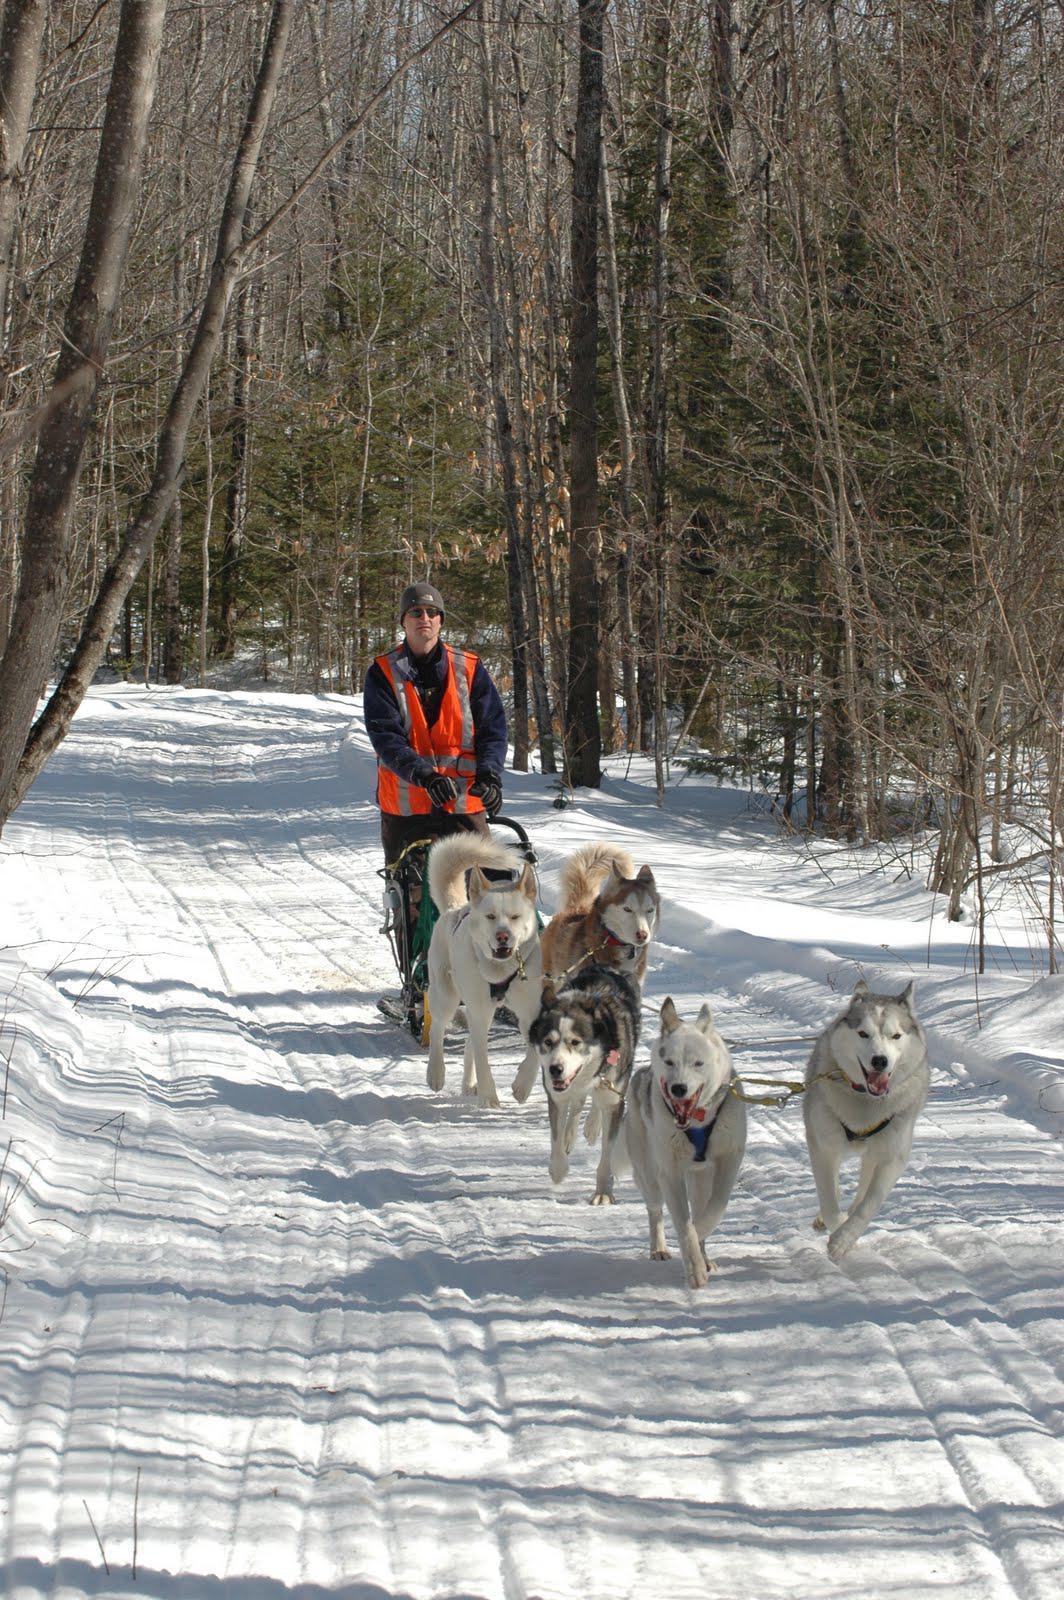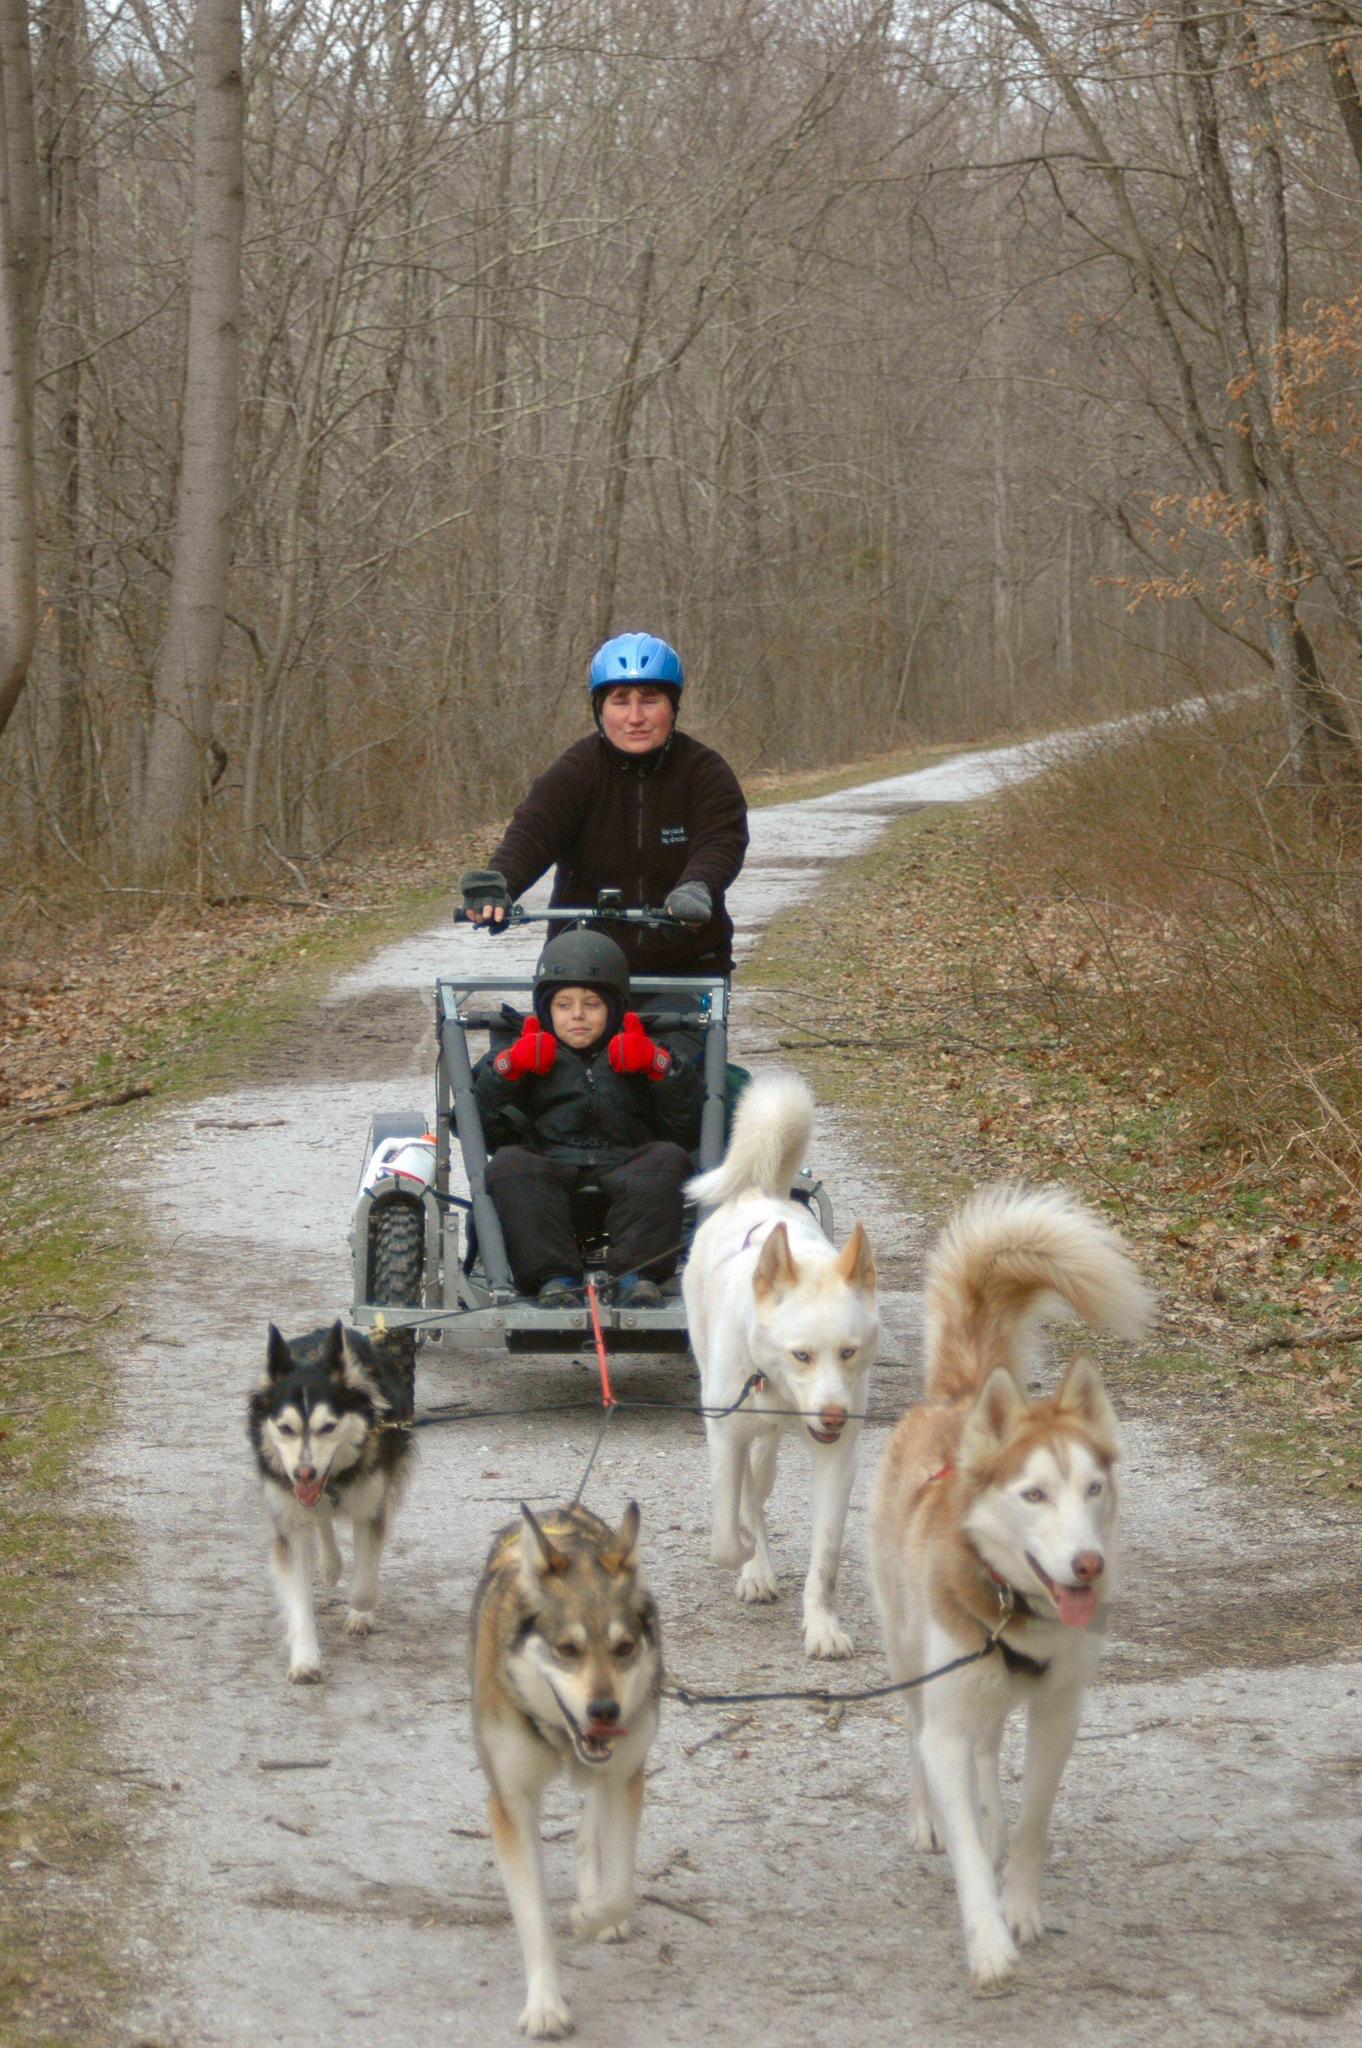The first image is the image on the left, the second image is the image on the right. Assess this claim about the two images: "A team of sled dogs is walking on a road that has no snow on it.". Correct or not? Answer yes or no. Yes. The first image is the image on the left, the second image is the image on the right. Assess this claim about the two images: "sled dogs are pulling a wagon on a dirt road". Correct or not? Answer yes or no. Yes. 